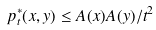<formula> <loc_0><loc_0><loc_500><loc_500>p ^ { * } _ { t } ( x , y ) \leq A ( x ) A ( y ) / t ^ { 2 }</formula> 